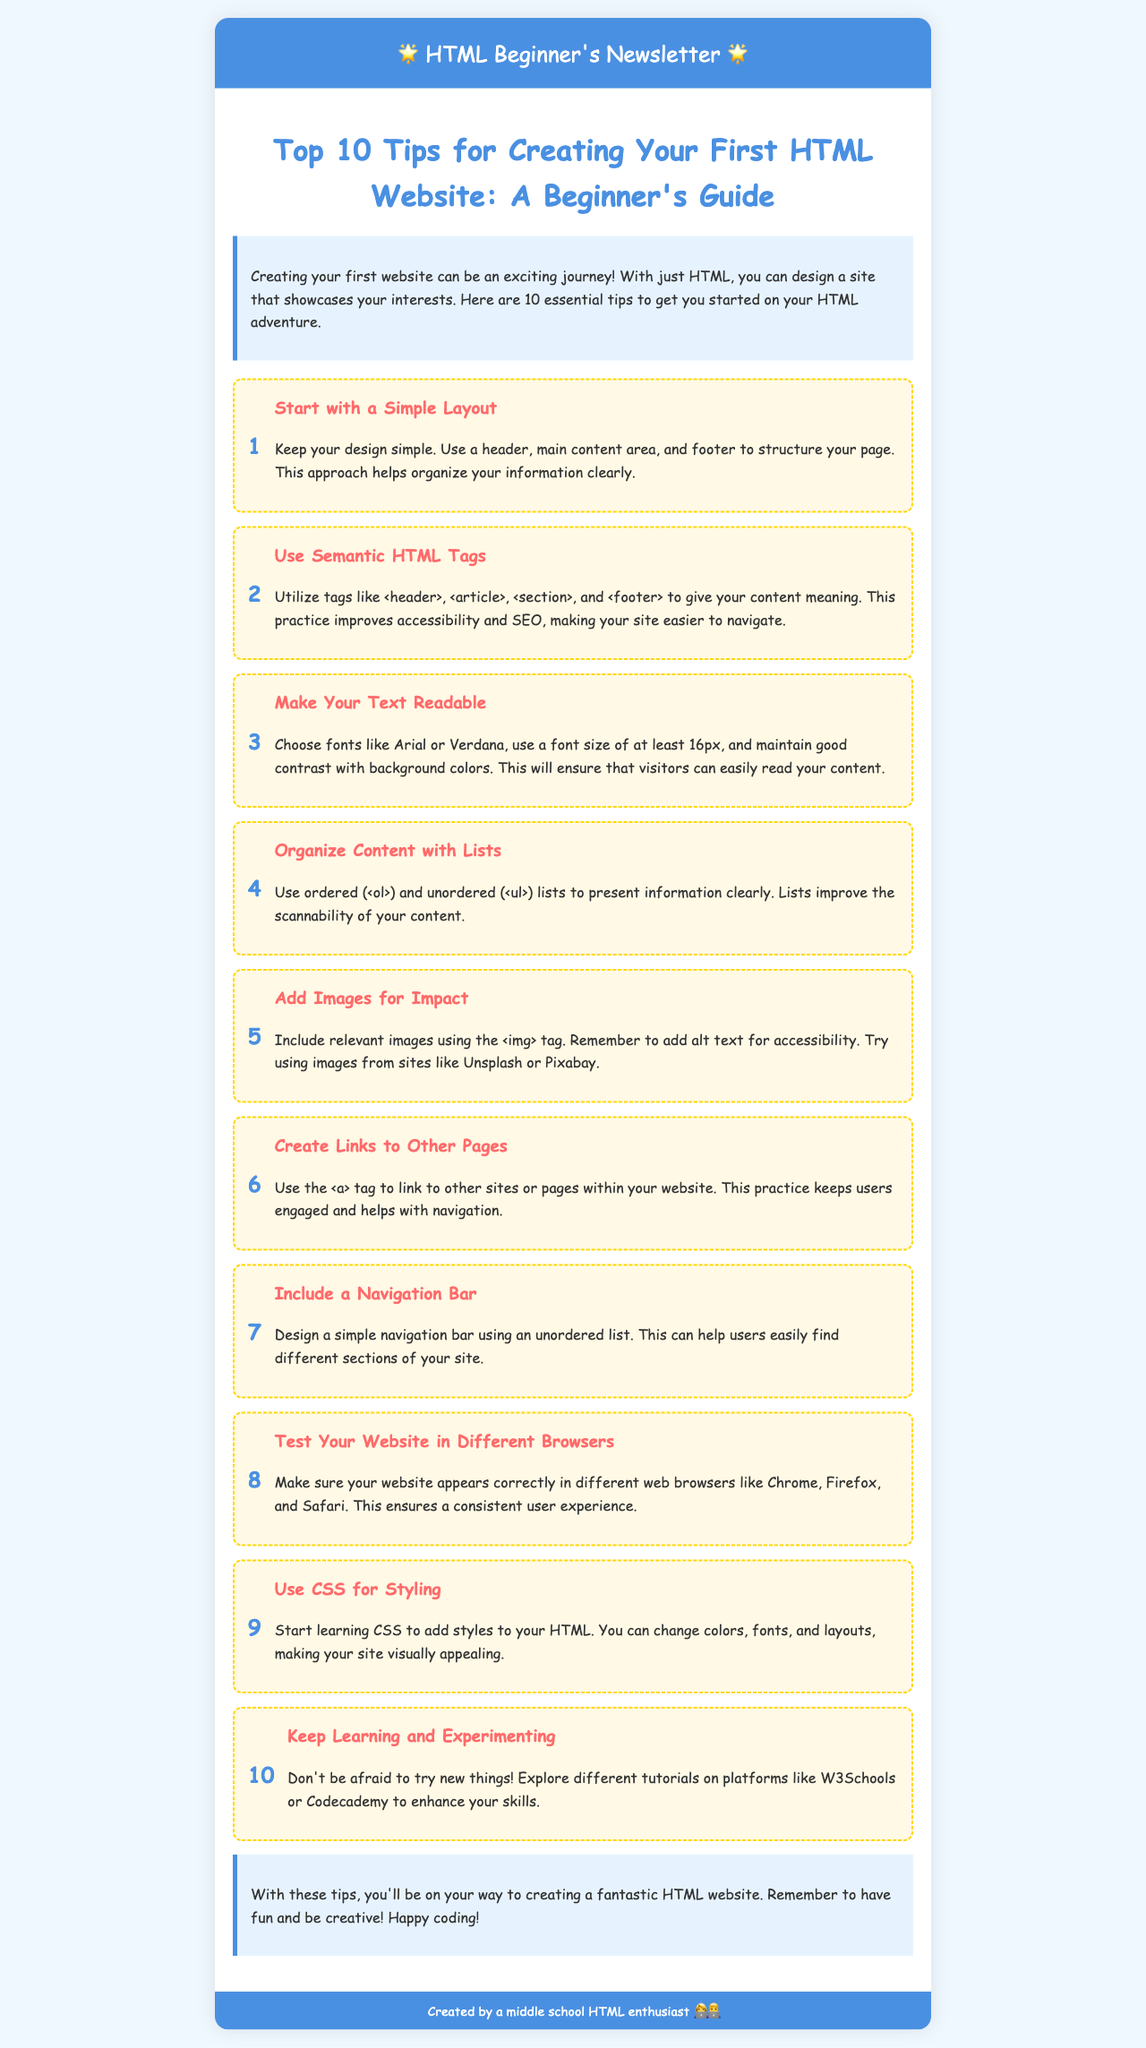What is the title of the newsletter? The title is stated clearly at the top of the content section in the document.
Answer: Top 10 Tips for Creating Your First HTML Website: A Beginner's Guide How many tips are provided in the newsletter? The number of tips is indicated by the content presented in the document.
Answer: 10 What color is the header background? The document specifies the header background color in the styling section.
Answer: #4a90e2 What is the first tip about? The first tip is outlined in the tips section and focuses on the structure of the website.
Answer: Start with a Simple Layout Which tag is recommended for links? The document explicitly states which HTML tag should be used for linking.
Answer: a What should you use to make your text readable? The document lists specific recommendations regarding font choices and sizes.
Answer: Fonts like Arial or Verdana, and at least 16px What does the conclusion encourage readers to do? The concluding section gives an important message wrapped up for beginners creating a website.
Answer: Have fun and be creative What background color is used for the intro section? The intro section’s background color is clearly described in the stylesheet.
Answer: #e6f3ff 